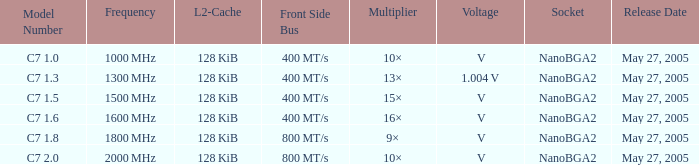What is the frequency of model number c7 1.0? 1000 MHz. 